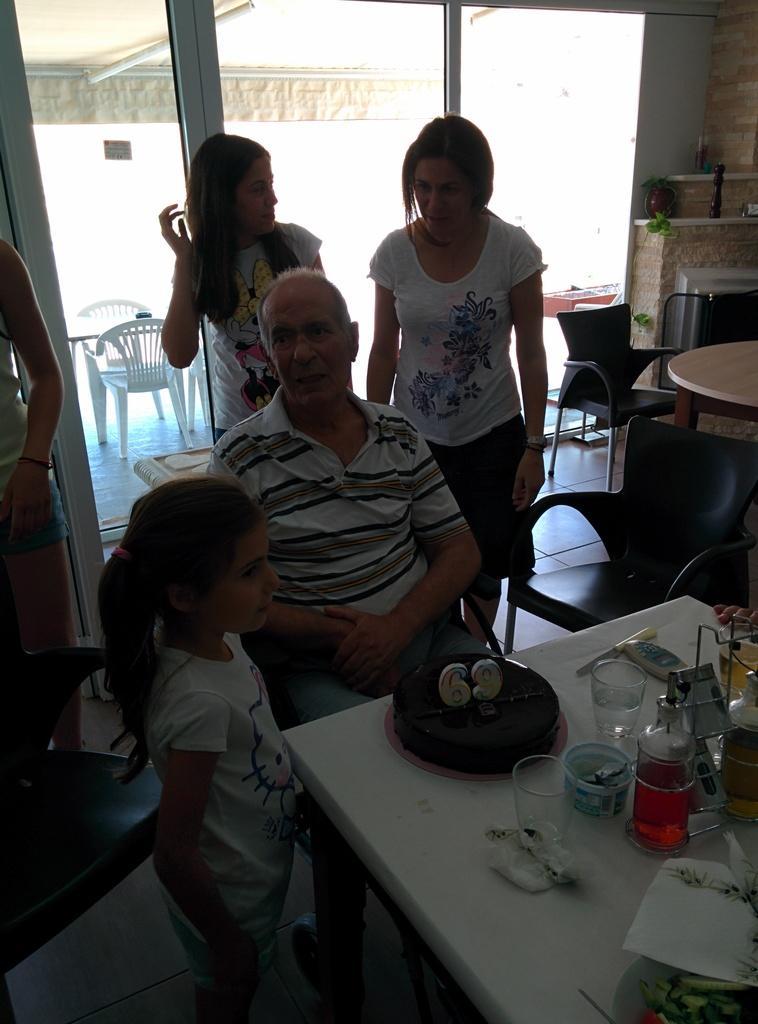Describe this image in one or two sentences. This is a picture taken in a room, there are a group of people in the room. There is a man who are sitting on a chair in front of the man there is a table on the table there is a glass, cup, bottle, cake. Background of this people is a window glass. 